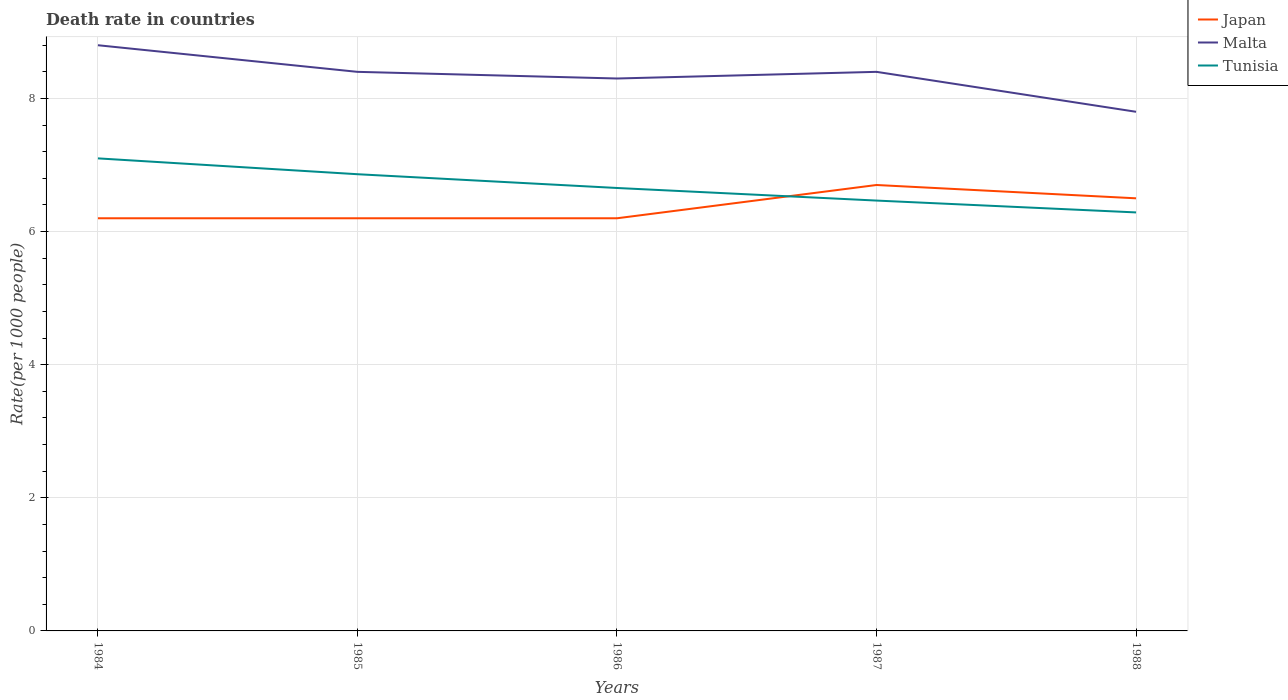Does the line corresponding to Tunisia intersect with the line corresponding to Malta?
Your response must be concise. No. Across all years, what is the maximum death rate in Malta?
Ensure brevity in your answer.  7.8. What is the total death rate in Tunisia in the graph?
Make the answer very short. 0.19. What is the difference between the highest and the second highest death rate in Malta?
Provide a succinct answer. 1. What is the difference between the highest and the lowest death rate in Tunisia?
Offer a very short reply. 2. How many lines are there?
Provide a succinct answer. 3. How many years are there in the graph?
Give a very brief answer. 5. Are the values on the major ticks of Y-axis written in scientific E-notation?
Provide a short and direct response. No. Does the graph contain grids?
Your answer should be very brief. Yes. How are the legend labels stacked?
Your answer should be very brief. Vertical. What is the title of the graph?
Offer a terse response. Death rate in countries. What is the label or title of the Y-axis?
Offer a very short reply. Rate(per 1000 people). What is the Rate(per 1000 people) of Japan in 1984?
Offer a very short reply. 6.2. What is the Rate(per 1000 people) in Malta in 1984?
Make the answer very short. 8.8. What is the Rate(per 1000 people) of Tunisia in 1984?
Your answer should be compact. 7.1. What is the Rate(per 1000 people) in Japan in 1985?
Your answer should be very brief. 6.2. What is the Rate(per 1000 people) of Malta in 1985?
Make the answer very short. 8.4. What is the Rate(per 1000 people) of Tunisia in 1985?
Provide a succinct answer. 6.86. What is the Rate(per 1000 people) in Japan in 1986?
Keep it short and to the point. 6.2. What is the Rate(per 1000 people) of Malta in 1986?
Your answer should be compact. 8.3. What is the Rate(per 1000 people) in Tunisia in 1986?
Your answer should be very brief. 6.66. What is the Rate(per 1000 people) in Tunisia in 1987?
Offer a very short reply. 6.47. What is the Rate(per 1000 people) in Tunisia in 1988?
Your answer should be compact. 6.29. Across all years, what is the maximum Rate(per 1000 people) of Tunisia?
Your answer should be very brief. 7.1. Across all years, what is the minimum Rate(per 1000 people) in Japan?
Provide a succinct answer. 6.2. Across all years, what is the minimum Rate(per 1000 people) in Malta?
Your answer should be very brief. 7.8. Across all years, what is the minimum Rate(per 1000 people) of Tunisia?
Keep it short and to the point. 6.29. What is the total Rate(per 1000 people) in Japan in the graph?
Provide a succinct answer. 31.8. What is the total Rate(per 1000 people) of Malta in the graph?
Make the answer very short. 41.7. What is the total Rate(per 1000 people) of Tunisia in the graph?
Your response must be concise. 33.37. What is the difference between the Rate(per 1000 people) in Japan in 1984 and that in 1985?
Your answer should be compact. 0. What is the difference between the Rate(per 1000 people) in Malta in 1984 and that in 1985?
Provide a short and direct response. 0.4. What is the difference between the Rate(per 1000 people) in Tunisia in 1984 and that in 1985?
Keep it short and to the point. 0.24. What is the difference between the Rate(per 1000 people) in Tunisia in 1984 and that in 1986?
Offer a terse response. 0.45. What is the difference between the Rate(per 1000 people) in Malta in 1984 and that in 1987?
Your answer should be compact. 0.4. What is the difference between the Rate(per 1000 people) in Tunisia in 1984 and that in 1987?
Your answer should be compact. 0.63. What is the difference between the Rate(per 1000 people) in Malta in 1984 and that in 1988?
Make the answer very short. 1. What is the difference between the Rate(per 1000 people) in Tunisia in 1984 and that in 1988?
Ensure brevity in your answer.  0.81. What is the difference between the Rate(per 1000 people) of Tunisia in 1985 and that in 1986?
Offer a terse response. 0.21. What is the difference between the Rate(per 1000 people) in Malta in 1985 and that in 1987?
Your response must be concise. 0. What is the difference between the Rate(per 1000 people) of Tunisia in 1985 and that in 1987?
Make the answer very short. 0.4. What is the difference between the Rate(per 1000 people) in Japan in 1985 and that in 1988?
Provide a short and direct response. -0.3. What is the difference between the Rate(per 1000 people) of Malta in 1985 and that in 1988?
Give a very brief answer. 0.6. What is the difference between the Rate(per 1000 people) in Tunisia in 1985 and that in 1988?
Ensure brevity in your answer.  0.57. What is the difference between the Rate(per 1000 people) in Tunisia in 1986 and that in 1987?
Your answer should be very brief. 0.19. What is the difference between the Rate(per 1000 people) of Tunisia in 1986 and that in 1988?
Offer a very short reply. 0.37. What is the difference between the Rate(per 1000 people) in Malta in 1987 and that in 1988?
Your response must be concise. 0.6. What is the difference between the Rate(per 1000 people) in Tunisia in 1987 and that in 1988?
Your answer should be compact. 0.18. What is the difference between the Rate(per 1000 people) in Japan in 1984 and the Rate(per 1000 people) in Malta in 1985?
Your answer should be compact. -2.2. What is the difference between the Rate(per 1000 people) of Japan in 1984 and the Rate(per 1000 people) of Tunisia in 1985?
Provide a short and direct response. -0.66. What is the difference between the Rate(per 1000 people) of Malta in 1984 and the Rate(per 1000 people) of Tunisia in 1985?
Give a very brief answer. 1.94. What is the difference between the Rate(per 1000 people) of Japan in 1984 and the Rate(per 1000 people) of Malta in 1986?
Offer a terse response. -2.1. What is the difference between the Rate(per 1000 people) in Japan in 1984 and the Rate(per 1000 people) in Tunisia in 1986?
Make the answer very short. -0.46. What is the difference between the Rate(per 1000 people) of Malta in 1984 and the Rate(per 1000 people) of Tunisia in 1986?
Provide a short and direct response. 2.15. What is the difference between the Rate(per 1000 people) of Japan in 1984 and the Rate(per 1000 people) of Tunisia in 1987?
Offer a terse response. -0.27. What is the difference between the Rate(per 1000 people) in Malta in 1984 and the Rate(per 1000 people) in Tunisia in 1987?
Give a very brief answer. 2.33. What is the difference between the Rate(per 1000 people) of Japan in 1984 and the Rate(per 1000 people) of Tunisia in 1988?
Your answer should be very brief. -0.09. What is the difference between the Rate(per 1000 people) of Malta in 1984 and the Rate(per 1000 people) of Tunisia in 1988?
Keep it short and to the point. 2.51. What is the difference between the Rate(per 1000 people) of Japan in 1985 and the Rate(per 1000 people) of Malta in 1986?
Give a very brief answer. -2.1. What is the difference between the Rate(per 1000 people) in Japan in 1985 and the Rate(per 1000 people) in Tunisia in 1986?
Make the answer very short. -0.46. What is the difference between the Rate(per 1000 people) of Malta in 1985 and the Rate(per 1000 people) of Tunisia in 1986?
Offer a very short reply. 1.75. What is the difference between the Rate(per 1000 people) in Japan in 1985 and the Rate(per 1000 people) in Tunisia in 1987?
Offer a very short reply. -0.27. What is the difference between the Rate(per 1000 people) in Malta in 1985 and the Rate(per 1000 people) in Tunisia in 1987?
Give a very brief answer. 1.93. What is the difference between the Rate(per 1000 people) in Japan in 1985 and the Rate(per 1000 people) in Malta in 1988?
Give a very brief answer. -1.6. What is the difference between the Rate(per 1000 people) in Japan in 1985 and the Rate(per 1000 people) in Tunisia in 1988?
Offer a terse response. -0.09. What is the difference between the Rate(per 1000 people) in Malta in 1985 and the Rate(per 1000 people) in Tunisia in 1988?
Make the answer very short. 2.11. What is the difference between the Rate(per 1000 people) of Japan in 1986 and the Rate(per 1000 people) of Malta in 1987?
Offer a very short reply. -2.2. What is the difference between the Rate(per 1000 people) in Japan in 1986 and the Rate(per 1000 people) in Tunisia in 1987?
Your answer should be very brief. -0.27. What is the difference between the Rate(per 1000 people) in Malta in 1986 and the Rate(per 1000 people) in Tunisia in 1987?
Offer a terse response. 1.83. What is the difference between the Rate(per 1000 people) of Japan in 1986 and the Rate(per 1000 people) of Tunisia in 1988?
Provide a succinct answer. -0.09. What is the difference between the Rate(per 1000 people) of Malta in 1986 and the Rate(per 1000 people) of Tunisia in 1988?
Offer a very short reply. 2.01. What is the difference between the Rate(per 1000 people) in Japan in 1987 and the Rate(per 1000 people) in Tunisia in 1988?
Your response must be concise. 0.41. What is the difference between the Rate(per 1000 people) of Malta in 1987 and the Rate(per 1000 people) of Tunisia in 1988?
Ensure brevity in your answer.  2.11. What is the average Rate(per 1000 people) of Japan per year?
Provide a succinct answer. 6.36. What is the average Rate(per 1000 people) of Malta per year?
Your response must be concise. 8.34. What is the average Rate(per 1000 people) in Tunisia per year?
Ensure brevity in your answer.  6.67. In the year 1984, what is the difference between the Rate(per 1000 people) of Japan and Rate(per 1000 people) of Malta?
Your answer should be compact. -2.6. In the year 1984, what is the difference between the Rate(per 1000 people) in Japan and Rate(per 1000 people) in Tunisia?
Provide a short and direct response. -0.9. In the year 1984, what is the difference between the Rate(per 1000 people) in Malta and Rate(per 1000 people) in Tunisia?
Give a very brief answer. 1.7. In the year 1985, what is the difference between the Rate(per 1000 people) of Japan and Rate(per 1000 people) of Malta?
Your answer should be very brief. -2.2. In the year 1985, what is the difference between the Rate(per 1000 people) of Japan and Rate(per 1000 people) of Tunisia?
Provide a succinct answer. -0.66. In the year 1985, what is the difference between the Rate(per 1000 people) of Malta and Rate(per 1000 people) of Tunisia?
Your response must be concise. 1.54. In the year 1986, what is the difference between the Rate(per 1000 people) in Japan and Rate(per 1000 people) in Tunisia?
Offer a terse response. -0.46. In the year 1986, what is the difference between the Rate(per 1000 people) in Malta and Rate(per 1000 people) in Tunisia?
Offer a terse response. 1.65. In the year 1987, what is the difference between the Rate(per 1000 people) of Japan and Rate(per 1000 people) of Malta?
Provide a succinct answer. -1.7. In the year 1987, what is the difference between the Rate(per 1000 people) of Japan and Rate(per 1000 people) of Tunisia?
Give a very brief answer. 0.23. In the year 1987, what is the difference between the Rate(per 1000 people) in Malta and Rate(per 1000 people) in Tunisia?
Your answer should be very brief. 1.93. In the year 1988, what is the difference between the Rate(per 1000 people) of Japan and Rate(per 1000 people) of Malta?
Provide a short and direct response. -1.3. In the year 1988, what is the difference between the Rate(per 1000 people) in Japan and Rate(per 1000 people) in Tunisia?
Your answer should be compact. 0.21. In the year 1988, what is the difference between the Rate(per 1000 people) of Malta and Rate(per 1000 people) of Tunisia?
Provide a succinct answer. 1.51. What is the ratio of the Rate(per 1000 people) in Malta in 1984 to that in 1985?
Provide a short and direct response. 1.05. What is the ratio of the Rate(per 1000 people) of Tunisia in 1984 to that in 1985?
Make the answer very short. 1.03. What is the ratio of the Rate(per 1000 people) in Japan in 1984 to that in 1986?
Your answer should be very brief. 1. What is the ratio of the Rate(per 1000 people) of Malta in 1984 to that in 1986?
Your answer should be compact. 1.06. What is the ratio of the Rate(per 1000 people) in Tunisia in 1984 to that in 1986?
Provide a succinct answer. 1.07. What is the ratio of the Rate(per 1000 people) of Japan in 1984 to that in 1987?
Offer a terse response. 0.93. What is the ratio of the Rate(per 1000 people) of Malta in 1984 to that in 1987?
Ensure brevity in your answer.  1.05. What is the ratio of the Rate(per 1000 people) of Tunisia in 1984 to that in 1987?
Give a very brief answer. 1.1. What is the ratio of the Rate(per 1000 people) of Japan in 1984 to that in 1988?
Keep it short and to the point. 0.95. What is the ratio of the Rate(per 1000 people) of Malta in 1984 to that in 1988?
Provide a succinct answer. 1.13. What is the ratio of the Rate(per 1000 people) of Tunisia in 1984 to that in 1988?
Make the answer very short. 1.13. What is the ratio of the Rate(per 1000 people) in Japan in 1985 to that in 1986?
Give a very brief answer. 1. What is the ratio of the Rate(per 1000 people) in Tunisia in 1985 to that in 1986?
Offer a very short reply. 1.03. What is the ratio of the Rate(per 1000 people) in Japan in 1985 to that in 1987?
Your answer should be compact. 0.93. What is the ratio of the Rate(per 1000 people) of Malta in 1985 to that in 1987?
Your answer should be compact. 1. What is the ratio of the Rate(per 1000 people) of Tunisia in 1985 to that in 1987?
Your answer should be compact. 1.06. What is the ratio of the Rate(per 1000 people) of Japan in 1985 to that in 1988?
Keep it short and to the point. 0.95. What is the ratio of the Rate(per 1000 people) of Tunisia in 1985 to that in 1988?
Provide a succinct answer. 1.09. What is the ratio of the Rate(per 1000 people) of Japan in 1986 to that in 1987?
Ensure brevity in your answer.  0.93. What is the ratio of the Rate(per 1000 people) in Malta in 1986 to that in 1987?
Offer a very short reply. 0.99. What is the ratio of the Rate(per 1000 people) of Tunisia in 1986 to that in 1987?
Keep it short and to the point. 1.03. What is the ratio of the Rate(per 1000 people) of Japan in 1986 to that in 1988?
Your response must be concise. 0.95. What is the ratio of the Rate(per 1000 people) of Malta in 1986 to that in 1988?
Provide a short and direct response. 1.06. What is the ratio of the Rate(per 1000 people) of Tunisia in 1986 to that in 1988?
Make the answer very short. 1.06. What is the ratio of the Rate(per 1000 people) in Japan in 1987 to that in 1988?
Your answer should be very brief. 1.03. What is the ratio of the Rate(per 1000 people) of Tunisia in 1987 to that in 1988?
Provide a succinct answer. 1.03. What is the difference between the highest and the second highest Rate(per 1000 people) of Malta?
Ensure brevity in your answer.  0.4. What is the difference between the highest and the second highest Rate(per 1000 people) of Tunisia?
Ensure brevity in your answer.  0.24. What is the difference between the highest and the lowest Rate(per 1000 people) of Malta?
Make the answer very short. 1. What is the difference between the highest and the lowest Rate(per 1000 people) in Tunisia?
Provide a succinct answer. 0.81. 